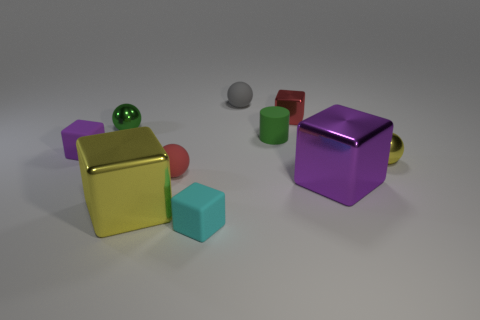Is there anything else of the same color as the cylinder?
Ensure brevity in your answer.  Yes. Is the number of yellow metallic objects to the left of the red metal thing greater than the number of big blue shiny blocks?
Provide a short and direct response. Yes. What number of metal things are green balls or cubes?
Offer a very short reply. 4. There is a metallic thing that is right of the yellow metallic cube and in front of the small red ball; what size is it?
Your response must be concise. Large. There is a tiny green object to the left of the gray matte object; is there a tiny rubber object that is in front of it?
Offer a very short reply. Yes. There is a tiny green shiny thing; how many objects are behind it?
Ensure brevity in your answer.  2. What color is the other rubber thing that is the same shape as the cyan object?
Your answer should be compact. Purple. Is the tiny cube on the left side of the large yellow thing made of the same material as the green object on the right side of the tiny gray rubber sphere?
Give a very brief answer. Yes. There is a tiny cylinder; is its color the same as the small rubber sphere that is right of the tiny red rubber object?
Your answer should be compact. No. What shape is the rubber thing that is both in front of the tiny green metallic thing and right of the cyan rubber thing?
Your response must be concise. Cylinder. 